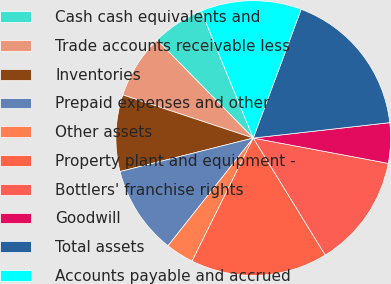Convert chart to OTSL. <chart><loc_0><loc_0><loc_500><loc_500><pie_chart><fcel>Cash cash equivalents and<fcel>Trade accounts receivable less<fcel>Inventories<fcel>Prepaid expenses and other<fcel>Other assets<fcel>Property plant and equipment -<fcel>Bottlers' franchise rights<fcel>Goodwill<fcel>Total assets<fcel>Accounts payable and accrued<nl><fcel>6.16%<fcel>7.58%<fcel>9.0%<fcel>10.43%<fcel>3.31%<fcel>16.12%<fcel>13.27%<fcel>4.74%<fcel>17.54%<fcel>11.85%<nl></chart> 